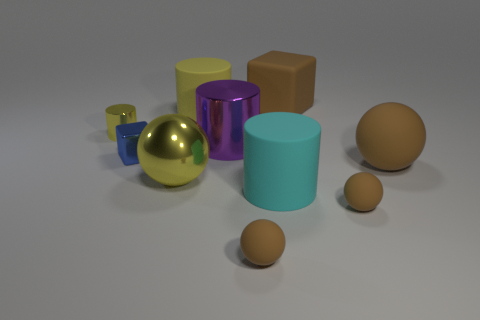What material is the big ball that is left of the large brown object behind the blue metallic block made of?
Ensure brevity in your answer.  Metal. There is a purple cylinder on the left side of the cyan rubber object; does it have the same size as the tiny cylinder?
Your answer should be compact. No. Are there any large objects that have the same color as the rubber block?
Ensure brevity in your answer.  Yes. What number of objects are either big rubber cylinders that are to the left of the purple object or large rubber cylinders behind the purple cylinder?
Provide a short and direct response. 1. Is the color of the big metal cylinder the same as the small metal cube?
Keep it short and to the point. No. What is the material of the sphere that is the same color as the tiny metallic cylinder?
Your answer should be very brief. Metal. Are there fewer small objects right of the shiny ball than objects to the left of the big brown matte cube?
Ensure brevity in your answer.  Yes. Do the purple cylinder and the small blue cube have the same material?
Your answer should be very brief. Yes. What is the size of the rubber object that is behind the large yellow shiny ball and on the left side of the brown block?
Ensure brevity in your answer.  Large. What is the shape of the purple object that is the same size as the cyan cylinder?
Keep it short and to the point. Cylinder. 